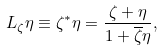Convert formula to latex. <formula><loc_0><loc_0><loc_500><loc_500>L _ { \zeta } \eta \equiv \zeta ^ { * } \eta = \frac { \zeta + \eta } { 1 + \overline { \zeta } \eta } ,</formula> 